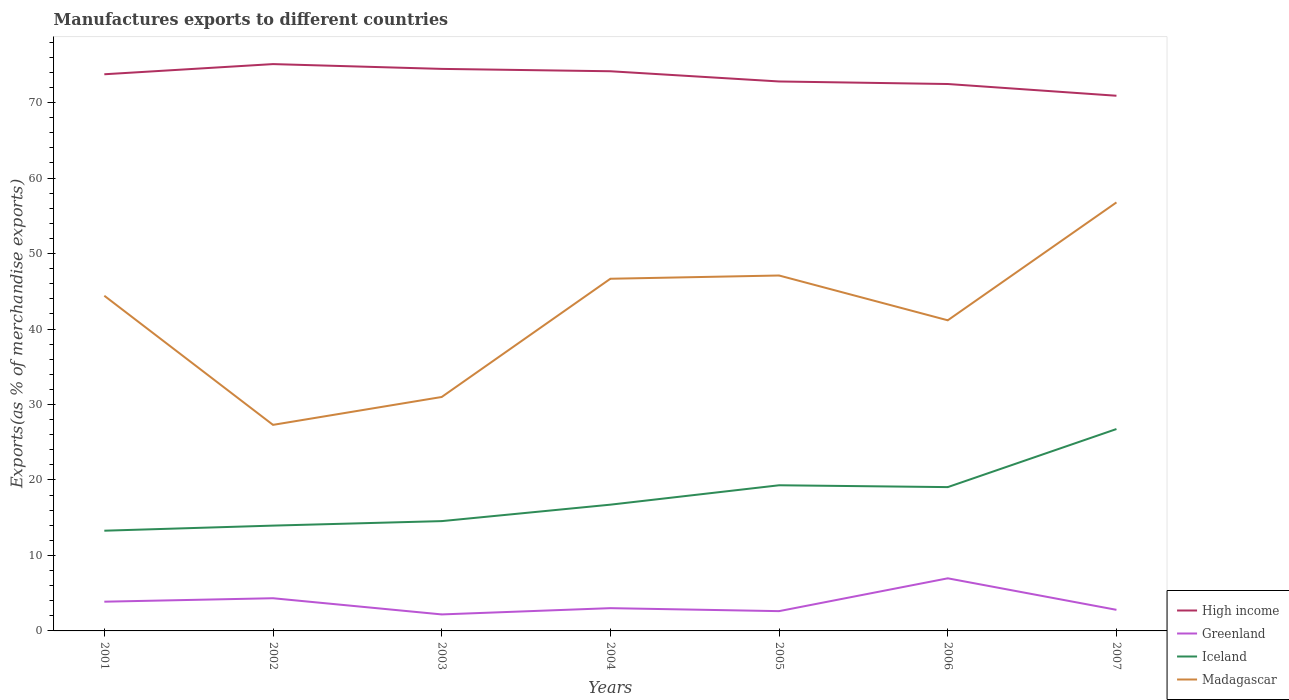Is the number of lines equal to the number of legend labels?
Your answer should be compact. Yes. Across all years, what is the maximum percentage of exports to different countries in Madagascar?
Make the answer very short. 27.3. What is the total percentage of exports to different countries in Iceland in the graph?
Offer a terse response. -3.45. What is the difference between the highest and the second highest percentage of exports to different countries in Greenland?
Offer a very short reply. 4.78. How many years are there in the graph?
Give a very brief answer. 7. Does the graph contain grids?
Give a very brief answer. No. What is the title of the graph?
Offer a very short reply. Manufactures exports to different countries. Does "Canada" appear as one of the legend labels in the graph?
Keep it short and to the point. No. What is the label or title of the Y-axis?
Make the answer very short. Exports(as % of merchandise exports). What is the Exports(as % of merchandise exports) of High income in 2001?
Ensure brevity in your answer.  73.76. What is the Exports(as % of merchandise exports) in Greenland in 2001?
Your answer should be very brief. 3.87. What is the Exports(as % of merchandise exports) in Iceland in 2001?
Provide a short and direct response. 13.28. What is the Exports(as % of merchandise exports) of Madagascar in 2001?
Provide a short and direct response. 44.41. What is the Exports(as % of merchandise exports) in High income in 2002?
Ensure brevity in your answer.  75.1. What is the Exports(as % of merchandise exports) in Greenland in 2002?
Ensure brevity in your answer.  4.33. What is the Exports(as % of merchandise exports) of Iceland in 2002?
Offer a terse response. 13.95. What is the Exports(as % of merchandise exports) of Madagascar in 2002?
Keep it short and to the point. 27.3. What is the Exports(as % of merchandise exports) in High income in 2003?
Give a very brief answer. 74.47. What is the Exports(as % of merchandise exports) in Greenland in 2003?
Your answer should be compact. 2.19. What is the Exports(as % of merchandise exports) in Iceland in 2003?
Give a very brief answer. 14.55. What is the Exports(as % of merchandise exports) of Madagascar in 2003?
Offer a very short reply. 31. What is the Exports(as % of merchandise exports) in High income in 2004?
Offer a very short reply. 74.16. What is the Exports(as % of merchandise exports) in Greenland in 2004?
Provide a short and direct response. 3.02. What is the Exports(as % of merchandise exports) in Iceland in 2004?
Give a very brief answer. 16.73. What is the Exports(as % of merchandise exports) in Madagascar in 2004?
Your response must be concise. 46.66. What is the Exports(as % of merchandise exports) of High income in 2005?
Your response must be concise. 72.8. What is the Exports(as % of merchandise exports) in Greenland in 2005?
Ensure brevity in your answer.  2.62. What is the Exports(as % of merchandise exports) of Iceland in 2005?
Provide a succinct answer. 19.3. What is the Exports(as % of merchandise exports) of Madagascar in 2005?
Keep it short and to the point. 47.09. What is the Exports(as % of merchandise exports) in High income in 2006?
Make the answer very short. 72.47. What is the Exports(as % of merchandise exports) of Greenland in 2006?
Your answer should be compact. 6.97. What is the Exports(as % of merchandise exports) of Iceland in 2006?
Provide a succinct answer. 19.05. What is the Exports(as % of merchandise exports) in Madagascar in 2006?
Make the answer very short. 41.16. What is the Exports(as % of merchandise exports) of High income in 2007?
Offer a terse response. 70.91. What is the Exports(as % of merchandise exports) in Greenland in 2007?
Ensure brevity in your answer.  2.8. What is the Exports(as % of merchandise exports) of Iceland in 2007?
Your response must be concise. 26.75. What is the Exports(as % of merchandise exports) of Madagascar in 2007?
Provide a succinct answer. 56.78. Across all years, what is the maximum Exports(as % of merchandise exports) of High income?
Provide a short and direct response. 75.1. Across all years, what is the maximum Exports(as % of merchandise exports) of Greenland?
Make the answer very short. 6.97. Across all years, what is the maximum Exports(as % of merchandise exports) of Iceland?
Ensure brevity in your answer.  26.75. Across all years, what is the maximum Exports(as % of merchandise exports) in Madagascar?
Your response must be concise. 56.78. Across all years, what is the minimum Exports(as % of merchandise exports) in High income?
Make the answer very short. 70.91. Across all years, what is the minimum Exports(as % of merchandise exports) in Greenland?
Offer a very short reply. 2.19. Across all years, what is the minimum Exports(as % of merchandise exports) of Iceland?
Provide a succinct answer. 13.28. Across all years, what is the minimum Exports(as % of merchandise exports) of Madagascar?
Provide a short and direct response. 27.3. What is the total Exports(as % of merchandise exports) in High income in the graph?
Your answer should be compact. 513.66. What is the total Exports(as % of merchandise exports) of Greenland in the graph?
Your response must be concise. 25.8. What is the total Exports(as % of merchandise exports) of Iceland in the graph?
Make the answer very short. 123.61. What is the total Exports(as % of merchandise exports) of Madagascar in the graph?
Provide a succinct answer. 294.4. What is the difference between the Exports(as % of merchandise exports) in High income in 2001 and that in 2002?
Keep it short and to the point. -1.35. What is the difference between the Exports(as % of merchandise exports) in Greenland in 2001 and that in 2002?
Offer a terse response. -0.46. What is the difference between the Exports(as % of merchandise exports) of Iceland in 2001 and that in 2002?
Ensure brevity in your answer.  -0.68. What is the difference between the Exports(as % of merchandise exports) in Madagascar in 2001 and that in 2002?
Your answer should be very brief. 17.11. What is the difference between the Exports(as % of merchandise exports) of High income in 2001 and that in 2003?
Your answer should be compact. -0.71. What is the difference between the Exports(as % of merchandise exports) of Greenland in 2001 and that in 2003?
Make the answer very short. 1.69. What is the difference between the Exports(as % of merchandise exports) of Iceland in 2001 and that in 2003?
Offer a terse response. -1.27. What is the difference between the Exports(as % of merchandise exports) of Madagascar in 2001 and that in 2003?
Keep it short and to the point. 13.41. What is the difference between the Exports(as % of merchandise exports) of High income in 2001 and that in 2004?
Give a very brief answer. -0.4. What is the difference between the Exports(as % of merchandise exports) in Greenland in 2001 and that in 2004?
Provide a succinct answer. 0.86. What is the difference between the Exports(as % of merchandise exports) in Iceland in 2001 and that in 2004?
Ensure brevity in your answer.  -3.45. What is the difference between the Exports(as % of merchandise exports) in Madagascar in 2001 and that in 2004?
Keep it short and to the point. -2.25. What is the difference between the Exports(as % of merchandise exports) of High income in 2001 and that in 2005?
Your answer should be very brief. 0.95. What is the difference between the Exports(as % of merchandise exports) in Greenland in 2001 and that in 2005?
Your response must be concise. 1.25. What is the difference between the Exports(as % of merchandise exports) of Iceland in 2001 and that in 2005?
Keep it short and to the point. -6.02. What is the difference between the Exports(as % of merchandise exports) in Madagascar in 2001 and that in 2005?
Make the answer very short. -2.68. What is the difference between the Exports(as % of merchandise exports) of High income in 2001 and that in 2006?
Make the answer very short. 1.29. What is the difference between the Exports(as % of merchandise exports) of Greenland in 2001 and that in 2006?
Offer a terse response. -3.1. What is the difference between the Exports(as % of merchandise exports) of Iceland in 2001 and that in 2006?
Your answer should be very brief. -5.78. What is the difference between the Exports(as % of merchandise exports) of Madagascar in 2001 and that in 2006?
Give a very brief answer. 3.25. What is the difference between the Exports(as % of merchandise exports) of High income in 2001 and that in 2007?
Give a very brief answer. 2.85. What is the difference between the Exports(as % of merchandise exports) in Greenland in 2001 and that in 2007?
Offer a terse response. 1.08. What is the difference between the Exports(as % of merchandise exports) in Iceland in 2001 and that in 2007?
Keep it short and to the point. -13.47. What is the difference between the Exports(as % of merchandise exports) of Madagascar in 2001 and that in 2007?
Your answer should be very brief. -12.37. What is the difference between the Exports(as % of merchandise exports) in High income in 2002 and that in 2003?
Your answer should be compact. 0.64. What is the difference between the Exports(as % of merchandise exports) of Greenland in 2002 and that in 2003?
Ensure brevity in your answer.  2.14. What is the difference between the Exports(as % of merchandise exports) of Iceland in 2002 and that in 2003?
Make the answer very short. -0.59. What is the difference between the Exports(as % of merchandise exports) in Madagascar in 2002 and that in 2003?
Ensure brevity in your answer.  -3.69. What is the difference between the Exports(as % of merchandise exports) in High income in 2002 and that in 2004?
Offer a very short reply. 0.95. What is the difference between the Exports(as % of merchandise exports) in Greenland in 2002 and that in 2004?
Ensure brevity in your answer.  1.31. What is the difference between the Exports(as % of merchandise exports) in Iceland in 2002 and that in 2004?
Offer a terse response. -2.77. What is the difference between the Exports(as % of merchandise exports) of Madagascar in 2002 and that in 2004?
Your response must be concise. -19.36. What is the difference between the Exports(as % of merchandise exports) in High income in 2002 and that in 2005?
Keep it short and to the point. 2.3. What is the difference between the Exports(as % of merchandise exports) of Greenland in 2002 and that in 2005?
Provide a short and direct response. 1.71. What is the difference between the Exports(as % of merchandise exports) of Iceland in 2002 and that in 2005?
Your answer should be compact. -5.34. What is the difference between the Exports(as % of merchandise exports) of Madagascar in 2002 and that in 2005?
Your answer should be compact. -19.79. What is the difference between the Exports(as % of merchandise exports) in High income in 2002 and that in 2006?
Ensure brevity in your answer.  2.64. What is the difference between the Exports(as % of merchandise exports) in Greenland in 2002 and that in 2006?
Provide a succinct answer. -2.64. What is the difference between the Exports(as % of merchandise exports) in Iceland in 2002 and that in 2006?
Keep it short and to the point. -5.1. What is the difference between the Exports(as % of merchandise exports) in Madagascar in 2002 and that in 2006?
Provide a short and direct response. -13.86. What is the difference between the Exports(as % of merchandise exports) of High income in 2002 and that in 2007?
Provide a short and direct response. 4.2. What is the difference between the Exports(as % of merchandise exports) of Greenland in 2002 and that in 2007?
Give a very brief answer. 1.54. What is the difference between the Exports(as % of merchandise exports) of Iceland in 2002 and that in 2007?
Your answer should be compact. -12.79. What is the difference between the Exports(as % of merchandise exports) in Madagascar in 2002 and that in 2007?
Your answer should be compact. -29.48. What is the difference between the Exports(as % of merchandise exports) in High income in 2003 and that in 2004?
Your answer should be compact. 0.31. What is the difference between the Exports(as % of merchandise exports) in Greenland in 2003 and that in 2004?
Give a very brief answer. -0.83. What is the difference between the Exports(as % of merchandise exports) of Iceland in 2003 and that in 2004?
Offer a very short reply. -2.18. What is the difference between the Exports(as % of merchandise exports) in Madagascar in 2003 and that in 2004?
Offer a terse response. -15.67. What is the difference between the Exports(as % of merchandise exports) in High income in 2003 and that in 2005?
Offer a terse response. 1.67. What is the difference between the Exports(as % of merchandise exports) in Greenland in 2003 and that in 2005?
Your answer should be very brief. -0.44. What is the difference between the Exports(as % of merchandise exports) in Iceland in 2003 and that in 2005?
Offer a terse response. -4.75. What is the difference between the Exports(as % of merchandise exports) of Madagascar in 2003 and that in 2005?
Your response must be concise. -16.1. What is the difference between the Exports(as % of merchandise exports) of High income in 2003 and that in 2006?
Your response must be concise. 2. What is the difference between the Exports(as % of merchandise exports) in Greenland in 2003 and that in 2006?
Give a very brief answer. -4.78. What is the difference between the Exports(as % of merchandise exports) in Iceland in 2003 and that in 2006?
Provide a succinct answer. -4.51. What is the difference between the Exports(as % of merchandise exports) of Madagascar in 2003 and that in 2006?
Provide a succinct answer. -10.16. What is the difference between the Exports(as % of merchandise exports) in High income in 2003 and that in 2007?
Your answer should be very brief. 3.56. What is the difference between the Exports(as % of merchandise exports) of Greenland in 2003 and that in 2007?
Keep it short and to the point. -0.61. What is the difference between the Exports(as % of merchandise exports) in Iceland in 2003 and that in 2007?
Ensure brevity in your answer.  -12.2. What is the difference between the Exports(as % of merchandise exports) of Madagascar in 2003 and that in 2007?
Provide a short and direct response. -25.78. What is the difference between the Exports(as % of merchandise exports) in High income in 2004 and that in 2005?
Offer a terse response. 1.35. What is the difference between the Exports(as % of merchandise exports) of Greenland in 2004 and that in 2005?
Offer a terse response. 0.4. What is the difference between the Exports(as % of merchandise exports) of Iceland in 2004 and that in 2005?
Ensure brevity in your answer.  -2.57. What is the difference between the Exports(as % of merchandise exports) in Madagascar in 2004 and that in 2005?
Keep it short and to the point. -0.43. What is the difference between the Exports(as % of merchandise exports) of High income in 2004 and that in 2006?
Your answer should be compact. 1.69. What is the difference between the Exports(as % of merchandise exports) of Greenland in 2004 and that in 2006?
Provide a short and direct response. -3.95. What is the difference between the Exports(as % of merchandise exports) in Iceland in 2004 and that in 2006?
Offer a very short reply. -2.33. What is the difference between the Exports(as % of merchandise exports) of Madagascar in 2004 and that in 2006?
Provide a succinct answer. 5.51. What is the difference between the Exports(as % of merchandise exports) in High income in 2004 and that in 2007?
Keep it short and to the point. 3.25. What is the difference between the Exports(as % of merchandise exports) of Greenland in 2004 and that in 2007?
Provide a succinct answer. 0.22. What is the difference between the Exports(as % of merchandise exports) in Iceland in 2004 and that in 2007?
Your response must be concise. -10.02. What is the difference between the Exports(as % of merchandise exports) of Madagascar in 2004 and that in 2007?
Ensure brevity in your answer.  -10.12. What is the difference between the Exports(as % of merchandise exports) in High income in 2005 and that in 2006?
Make the answer very short. 0.34. What is the difference between the Exports(as % of merchandise exports) of Greenland in 2005 and that in 2006?
Provide a short and direct response. -4.35. What is the difference between the Exports(as % of merchandise exports) in Iceland in 2005 and that in 2006?
Keep it short and to the point. 0.24. What is the difference between the Exports(as % of merchandise exports) in Madagascar in 2005 and that in 2006?
Your answer should be very brief. 5.94. What is the difference between the Exports(as % of merchandise exports) of High income in 2005 and that in 2007?
Offer a very short reply. 1.89. What is the difference between the Exports(as % of merchandise exports) of Greenland in 2005 and that in 2007?
Your answer should be compact. -0.17. What is the difference between the Exports(as % of merchandise exports) of Iceland in 2005 and that in 2007?
Give a very brief answer. -7.45. What is the difference between the Exports(as % of merchandise exports) of Madagascar in 2005 and that in 2007?
Offer a very short reply. -9.69. What is the difference between the Exports(as % of merchandise exports) in High income in 2006 and that in 2007?
Your answer should be very brief. 1.56. What is the difference between the Exports(as % of merchandise exports) in Greenland in 2006 and that in 2007?
Make the answer very short. 4.17. What is the difference between the Exports(as % of merchandise exports) of Iceland in 2006 and that in 2007?
Provide a succinct answer. -7.69. What is the difference between the Exports(as % of merchandise exports) of Madagascar in 2006 and that in 2007?
Keep it short and to the point. -15.62. What is the difference between the Exports(as % of merchandise exports) of High income in 2001 and the Exports(as % of merchandise exports) of Greenland in 2002?
Give a very brief answer. 69.43. What is the difference between the Exports(as % of merchandise exports) of High income in 2001 and the Exports(as % of merchandise exports) of Iceland in 2002?
Offer a very short reply. 59.8. What is the difference between the Exports(as % of merchandise exports) in High income in 2001 and the Exports(as % of merchandise exports) in Madagascar in 2002?
Provide a short and direct response. 46.46. What is the difference between the Exports(as % of merchandise exports) of Greenland in 2001 and the Exports(as % of merchandise exports) of Iceland in 2002?
Provide a short and direct response. -10.08. What is the difference between the Exports(as % of merchandise exports) in Greenland in 2001 and the Exports(as % of merchandise exports) in Madagascar in 2002?
Offer a terse response. -23.43. What is the difference between the Exports(as % of merchandise exports) of Iceland in 2001 and the Exports(as % of merchandise exports) of Madagascar in 2002?
Offer a very short reply. -14.02. What is the difference between the Exports(as % of merchandise exports) in High income in 2001 and the Exports(as % of merchandise exports) in Greenland in 2003?
Give a very brief answer. 71.57. What is the difference between the Exports(as % of merchandise exports) in High income in 2001 and the Exports(as % of merchandise exports) in Iceland in 2003?
Ensure brevity in your answer.  59.21. What is the difference between the Exports(as % of merchandise exports) of High income in 2001 and the Exports(as % of merchandise exports) of Madagascar in 2003?
Your answer should be compact. 42.76. What is the difference between the Exports(as % of merchandise exports) in Greenland in 2001 and the Exports(as % of merchandise exports) in Iceland in 2003?
Offer a very short reply. -10.67. What is the difference between the Exports(as % of merchandise exports) of Greenland in 2001 and the Exports(as % of merchandise exports) of Madagascar in 2003?
Your answer should be compact. -27.12. What is the difference between the Exports(as % of merchandise exports) in Iceland in 2001 and the Exports(as % of merchandise exports) in Madagascar in 2003?
Offer a terse response. -17.72. What is the difference between the Exports(as % of merchandise exports) in High income in 2001 and the Exports(as % of merchandise exports) in Greenland in 2004?
Your answer should be very brief. 70.74. What is the difference between the Exports(as % of merchandise exports) of High income in 2001 and the Exports(as % of merchandise exports) of Iceland in 2004?
Provide a short and direct response. 57.03. What is the difference between the Exports(as % of merchandise exports) of High income in 2001 and the Exports(as % of merchandise exports) of Madagascar in 2004?
Ensure brevity in your answer.  27.09. What is the difference between the Exports(as % of merchandise exports) in Greenland in 2001 and the Exports(as % of merchandise exports) in Iceland in 2004?
Your response must be concise. -12.85. What is the difference between the Exports(as % of merchandise exports) of Greenland in 2001 and the Exports(as % of merchandise exports) of Madagascar in 2004?
Offer a terse response. -42.79. What is the difference between the Exports(as % of merchandise exports) of Iceland in 2001 and the Exports(as % of merchandise exports) of Madagascar in 2004?
Provide a succinct answer. -33.39. What is the difference between the Exports(as % of merchandise exports) of High income in 2001 and the Exports(as % of merchandise exports) of Greenland in 2005?
Offer a very short reply. 71.14. What is the difference between the Exports(as % of merchandise exports) in High income in 2001 and the Exports(as % of merchandise exports) in Iceland in 2005?
Ensure brevity in your answer.  54.46. What is the difference between the Exports(as % of merchandise exports) of High income in 2001 and the Exports(as % of merchandise exports) of Madagascar in 2005?
Offer a very short reply. 26.66. What is the difference between the Exports(as % of merchandise exports) of Greenland in 2001 and the Exports(as % of merchandise exports) of Iceland in 2005?
Keep it short and to the point. -15.42. What is the difference between the Exports(as % of merchandise exports) of Greenland in 2001 and the Exports(as % of merchandise exports) of Madagascar in 2005?
Your response must be concise. -43.22. What is the difference between the Exports(as % of merchandise exports) of Iceland in 2001 and the Exports(as % of merchandise exports) of Madagascar in 2005?
Give a very brief answer. -33.81. What is the difference between the Exports(as % of merchandise exports) of High income in 2001 and the Exports(as % of merchandise exports) of Greenland in 2006?
Your answer should be compact. 66.79. What is the difference between the Exports(as % of merchandise exports) of High income in 2001 and the Exports(as % of merchandise exports) of Iceland in 2006?
Provide a short and direct response. 54.7. What is the difference between the Exports(as % of merchandise exports) in High income in 2001 and the Exports(as % of merchandise exports) in Madagascar in 2006?
Ensure brevity in your answer.  32.6. What is the difference between the Exports(as % of merchandise exports) in Greenland in 2001 and the Exports(as % of merchandise exports) in Iceland in 2006?
Keep it short and to the point. -15.18. What is the difference between the Exports(as % of merchandise exports) in Greenland in 2001 and the Exports(as % of merchandise exports) in Madagascar in 2006?
Your answer should be compact. -37.28. What is the difference between the Exports(as % of merchandise exports) of Iceland in 2001 and the Exports(as % of merchandise exports) of Madagascar in 2006?
Give a very brief answer. -27.88. What is the difference between the Exports(as % of merchandise exports) in High income in 2001 and the Exports(as % of merchandise exports) in Greenland in 2007?
Give a very brief answer. 70.96. What is the difference between the Exports(as % of merchandise exports) in High income in 2001 and the Exports(as % of merchandise exports) in Iceland in 2007?
Provide a succinct answer. 47.01. What is the difference between the Exports(as % of merchandise exports) of High income in 2001 and the Exports(as % of merchandise exports) of Madagascar in 2007?
Your response must be concise. 16.98. What is the difference between the Exports(as % of merchandise exports) of Greenland in 2001 and the Exports(as % of merchandise exports) of Iceland in 2007?
Ensure brevity in your answer.  -22.88. What is the difference between the Exports(as % of merchandise exports) in Greenland in 2001 and the Exports(as % of merchandise exports) in Madagascar in 2007?
Provide a short and direct response. -52.9. What is the difference between the Exports(as % of merchandise exports) of Iceland in 2001 and the Exports(as % of merchandise exports) of Madagascar in 2007?
Give a very brief answer. -43.5. What is the difference between the Exports(as % of merchandise exports) in High income in 2002 and the Exports(as % of merchandise exports) in Greenland in 2003?
Keep it short and to the point. 72.92. What is the difference between the Exports(as % of merchandise exports) in High income in 2002 and the Exports(as % of merchandise exports) in Iceland in 2003?
Provide a short and direct response. 60.56. What is the difference between the Exports(as % of merchandise exports) in High income in 2002 and the Exports(as % of merchandise exports) in Madagascar in 2003?
Provide a short and direct response. 44.11. What is the difference between the Exports(as % of merchandise exports) in Greenland in 2002 and the Exports(as % of merchandise exports) in Iceland in 2003?
Your answer should be very brief. -10.22. What is the difference between the Exports(as % of merchandise exports) of Greenland in 2002 and the Exports(as % of merchandise exports) of Madagascar in 2003?
Provide a short and direct response. -26.66. What is the difference between the Exports(as % of merchandise exports) in Iceland in 2002 and the Exports(as % of merchandise exports) in Madagascar in 2003?
Give a very brief answer. -17.04. What is the difference between the Exports(as % of merchandise exports) in High income in 2002 and the Exports(as % of merchandise exports) in Greenland in 2004?
Your answer should be very brief. 72.09. What is the difference between the Exports(as % of merchandise exports) of High income in 2002 and the Exports(as % of merchandise exports) of Iceland in 2004?
Offer a terse response. 58.38. What is the difference between the Exports(as % of merchandise exports) in High income in 2002 and the Exports(as % of merchandise exports) in Madagascar in 2004?
Offer a terse response. 28.44. What is the difference between the Exports(as % of merchandise exports) in Greenland in 2002 and the Exports(as % of merchandise exports) in Iceland in 2004?
Provide a succinct answer. -12.4. What is the difference between the Exports(as % of merchandise exports) in Greenland in 2002 and the Exports(as % of merchandise exports) in Madagascar in 2004?
Your answer should be compact. -42.33. What is the difference between the Exports(as % of merchandise exports) in Iceland in 2002 and the Exports(as % of merchandise exports) in Madagascar in 2004?
Provide a succinct answer. -32.71. What is the difference between the Exports(as % of merchandise exports) in High income in 2002 and the Exports(as % of merchandise exports) in Greenland in 2005?
Offer a very short reply. 72.48. What is the difference between the Exports(as % of merchandise exports) in High income in 2002 and the Exports(as % of merchandise exports) in Iceland in 2005?
Give a very brief answer. 55.81. What is the difference between the Exports(as % of merchandise exports) in High income in 2002 and the Exports(as % of merchandise exports) in Madagascar in 2005?
Ensure brevity in your answer.  28.01. What is the difference between the Exports(as % of merchandise exports) of Greenland in 2002 and the Exports(as % of merchandise exports) of Iceland in 2005?
Provide a succinct answer. -14.97. What is the difference between the Exports(as % of merchandise exports) in Greenland in 2002 and the Exports(as % of merchandise exports) in Madagascar in 2005?
Your response must be concise. -42.76. What is the difference between the Exports(as % of merchandise exports) of Iceland in 2002 and the Exports(as % of merchandise exports) of Madagascar in 2005?
Your answer should be very brief. -33.14. What is the difference between the Exports(as % of merchandise exports) of High income in 2002 and the Exports(as % of merchandise exports) of Greenland in 2006?
Ensure brevity in your answer.  68.13. What is the difference between the Exports(as % of merchandise exports) in High income in 2002 and the Exports(as % of merchandise exports) in Iceland in 2006?
Your response must be concise. 56.05. What is the difference between the Exports(as % of merchandise exports) of High income in 2002 and the Exports(as % of merchandise exports) of Madagascar in 2006?
Ensure brevity in your answer.  33.95. What is the difference between the Exports(as % of merchandise exports) in Greenland in 2002 and the Exports(as % of merchandise exports) in Iceland in 2006?
Offer a very short reply. -14.72. What is the difference between the Exports(as % of merchandise exports) in Greenland in 2002 and the Exports(as % of merchandise exports) in Madagascar in 2006?
Your answer should be compact. -36.83. What is the difference between the Exports(as % of merchandise exports) of Iceland in 2002 and the Exports(as % of merchandise exports) of Madagascar in 2006?
Give a very brief answer. -27.2. What is the difference between the Exports(as % of merchandise exports) of High income in 2002 and the Exports(as % of merchandise exports) of Greenland in 2007?
Your answer should be very brief. 72.31. What is the difference between the Exports(as % of merchandise exports) in High income in 2002 and the Exports(as % of merchandise exports) in Iceland in 2007?
Ensure brevity in your answer.  48.36. What is the difference between the Exports(as % of merchandise exports) of High income in 2002 and the Exports(as % of merchandise exports) of Madagascar in 2007?
Ensure brevity in your answer.  18.33. What is the difference between the Exports(as % of merchandise exports) in Greenland in 2002 and the Exports(as % of merchandise exports) in Iceland in 2007?
Provide a short and direct response. -22.42. What is the difference between the Exports(as % of merchandise exports) in Greenland in 2002 and the Exports(as % of merchandise exports) in Madagascar in 2007?
Give a very brief answer. -52.45. What is the difference between the Exports(as % of merchandise exports) of Iceland in 2002 and the Exports(as % of merchandise exports) of Madagascar in 2007?
Offer a terse response. -42.82. What is the difference between the Exports(as % of merchandise exports) of High income in 2003 and the Exports(as % of merchandise exports) of Greenland in 2004?
Offer a terse response. 71.45. What is the difference between the Exports(as % of merchandise exports) of High income in 2003 and the Exports(as % of merchandise exports) of Iceland in 2004?
Make the answer very short. 57.74. What is the difference between the Exports(as % of merchandise exports) in High income in 2003 and the Exports(as % of merchandise exports) in Madagascar in 2004?
Give a very brief answer. 27.8. What is the difference between the Exports(as % of merchandise exports) of Greenland in 2003 and the Exports(as % of merchandise exports) of Iceland in 2004?
Provide a succinct answer. -14.54. What is the difference between the Exports(as % of merchandise exports) in Greenland in 2003 and the Exports(as % of merchandise exports) in Madagascar in 2004?
Provide a succinct answer. -44.48. What is the difference between the Exports(as % of merchandise exports) of Iceland in 2003 and the Exports(as % of merchandise exports) of Madagascar in 2004?
Offer a terse response. -32.11. What is the difference between the Exports(as % of merchandise exports) of High income in 2003 and the Exports(as % of merchandise exports) of Greenland in 2005?
Offer a very short reply. 71.85. What is the difference between the Exports(as % of merchandise exports) in High income in 2003 and the Exports(as % of merchandise exports) in Iceland in 2005?
Your response must be concise. 55.17. What is the difference between the Exports(as % of merchandise exports) in High income in 2003 and the Exports(as % of merchandise exports) in Madagascar in 2005?
Your response must be concise. 27.38. What is the difference between the Exports(as % of merchandise exports) of Greenland in 2003 and the Exports(as % of merchandise exports) of Iceland in 2005?
Your answer should be very brief. -17.11. What is the difference between the Exports(as % of merchandise exports) in Greenland in 2003 and the Exports(as % of merchandise exports) in Madagascar in 2005?
Ensure brevity in your answer.  -44.91. What is the difference between the Exports(as % of merchandise exports) in Iceland in 2003 and the Exports(as % of merchandise exports) in Madagascar in 2005?
Provide a short and direct response. -32.54. What is the difference between the Exports(as % of merchandise exports) in High income in 2003 and the Exports(as % of merchandise exports) in Greenland in 2006?
Ensure brevity in your answer.  67.5. What is the difference between the Exports(as % of merchandise exports) in High income in 2003 and the Exports(as % of merchandise exports) in Iceland in 2006?
Your response must be concise. 55.41. What is the difference between the Exports(as % of merchandise exports) in High income in 2003 and the Exports(as % of merchandise exports) in Madagascar in 2006?
Provide a succinct answer. 33.31. What is the difference between the Exports(as % of merchandise exports) of Greenland in 2003 and the Exports(as % of merchandise exports) of Iceland in 2006?
Your answer should be compact. -16.87. What is the difference between the Exports(as % of merchandise exports) in Greenland in 2003 and the Exports(as % of merchandise exports) in Madagascar in 2006?
Offer a very short reply. -38.97. What is the difference between the Exports(as % of merchandise exports) of Iceland in 2003 and the Exports(as % of merchandise exports) of Madagascar in 2006?
Ensure brevity in your answer.  -26.61. What is the difference between the Exports(as % of merchandise exports) in High income in 2003 and the Exports(as % of merchandise exports) in Greenland in 2007?
Provide a short and direct response. 71.67. What is the difference between the Exports(as % of merchandise exports) in High income in 2003 and the Exports(as % of merchandise exports) in Iceland in 2007?
Make the answer very short. 47.72. What is the difference between the Exports(as % of merchandise exports) in High income in 2003 and the Exports(as % of merchandise exports) in Madagascar in 2007?
Give a very brief answer. 17.69. What is the difference between the Exports(as % of merchandise exports) of Greenland in 2003 and the Exports(as % of merchandise exports) of Iceland in 2007?
Your response must be concise. -24.56. What is the difference between the Exports(as % of merchandise exports) of Greenland in 2003 and the Exports(as % of merchandise exports) of Madagascar in 2007?
Give a very brief answer. -54.59. What is the difference between the Exports(as % of merchandise exports) in Iceland in 2003 and the Exports(as % of merchandise exports) in Madagascar in 2007?
Offer a very short reply. -42.23. What is the difference between the Exports(as % of merchandise exports) of High income in 2004 and the Exports(as % of merchandise exports) of Greenland in 2005?
Offer a very short reply. 71.54. What is the difference between the Exports(as % of merchandise exports) in High income in 2004 and the Exports(as % of merchandise exports) in Iceland in 2005?
Make the answer very short. 54.86. What is the difference between the Exports(as % of merchandise exports) of High income in 2004 and the Exports(as % of merchandise exports) of Madagascar in 2005?
Provide a succinct answer. 27.06. What is the difference between the Exports(as % of merchandise exports) of Greenland in 2004 and the Exports(as % of merchandise exports) of Iceland in 2005?
Your answer should be compact. -16.28. What is the difference between the Exports(as % of merchandise exports) in Greenland in 2004 and the Exports(as % of merchandise exports) in Madagascar in 2005?
Ensure brevity in your answer.  -44.08. What is the difference between the Exports(as % of merchandise exports) in Iceland in 2004 and the Exports(as % of merchandise exports) in Madagascar in 2005?
Your answer should be compact. -30.36. What is the difference between the Exports(as % of merchandise exports) of High income in 2004 and the Exports(as % of merchandise exports) of Greenland in 2006?
Your response must be concise. 67.19. What is the difference between the Exports(as % of merchandise exports) in High income in 2004 and the Exports(as % of merchandise exports) in Iceland in 2006?
Offer a very short reply. 55.1. What is the difference between the Exports(as % of merchandise exports) in High income in 2004 and the Exports(as % of merchandise exports) in Madagascar in 2006?
Provide a short and direct response. 33. What is the difference between the Exports(as % of merchandise exports) of Greenland in 2004 and the Exports(as % of merchandise exports) of Iceland in 2006?
Provide a succinct answer. -16.04. What is the difference between the Exports(as % of merchandise exports) of Greenland in 2004 and the Exports(as % of merchandise exports) of Madagascar in 2006?
Ensure brevity in your answer.  -38.14. What is the difference between the Exports(as % of merchandise exports) of Iceland in 2004 and the Exports(as % of merchandise exports) of Madagascar in 2006?
Your response must be concise. -24.43. What is the difference between the Exports(as % of merchandise exports) in High income in 2004 and the Exports(as % of merchandise exports) in Greenland in 2007?
Your answer should be very brief. 71.36. What is the difference between the Exports(as % of merchandise exports) of High income in 2004 and the Exports(as % of merchandise exports) of Iceland in 2007?
Make the answer very short. 47.41. What is the difference between the Exports(as % of merchandise exports) in High income in 2004 and the Exports(as % of merchandise exports) in Madagascar in 2007?
Your answer should be compact. 17.38. What is the difference between the Exports(as % of merchandise exports) in Greenland in 2004 and the Exports(as % of merchandise exports) in Iceland in 2007?
Provide a short and direct response. -23.73. What is the difference between the Exports(as % of merchandise exports) in Greenland in 2004 and the Exports(as % of merchandise exports) in Madagascar in 2007?
Your answer should be compact. -53.76. What is the difference between the Exports(as % of merchandise exports) in Iceland in 2004 and the Exports(as % of merchandise exports) in Madagascar in 2007?
Offer a very short reply. -40.05. What is the difference between the Exports(as % of merchandise exports) of High income in 2005 and the Exports(as % of merchandise exports) of Greenland in 2006?
Your answer should be compact. 65.83. What is the difference between the Exports(as % of merchandise exports) of High income in 2005 and the Exports(as % of merchandise exports) of Iceland in 2006?
Give a very brief answer. 53.75. What is the difference between the Exports(as % of merchandise exports) in High income in 2005 and the Exports(as % of merchandise exports) in Madagascar in 2006?
Provide a short and direct response. 31.64. What is the difference between the Exports(as % of merchandise exports) of Greenland in 2005 and the Exports(as % of merchandise exports) of Iceland in 2006?
Keep it short and to the point. -16.43. What is the difference between the Exports(as % of merchandise exports) in Greenland in 2005 and the Exports(as % of merchandise exports) in Madagascar in 2006?
Give a very brief answer. -38.54. What is the difference between the Exports(as % of merchandise exports) in Iceland in 2005 and the Exports(as % of merchandise exports) in Madagascar in 2006?
Your answer should be compact. -21.86. What is the difference between the Exports(as % of merchandise exports) in High income in 2005 and the Exports(as % of merchandise exports) in Greenland in 2007?
Your answer should be very brief. 70.01. What is the difference between the Exports(as % of merchandise exports) in High income in 2005 and the Exports(as % of merchandise exports) in Iceland in 2007?
Give a very brief answer. 46.05. What is the difference between the Exports(as % of merchandise exports) of High income in 2005 and the Exports(as % of merchandise exports) of Madagascar in 2007?
Keep it short and to the point. 16.02. What is the difference between the Exports(as % of merchandise exports) in Greenland in 2005 and the Exports(as % of merchandise exports) in Iceland in 2007?
Provide a succinct answer. -24.13. What is the difference between the Exports(as % of merchandise exports) in Greenland in 2005 and the Exports(as % of merchandise exports) in Madagascar in 2007?
Make the answer very short. -54.16. What is the difference between the Exports(as % of merchandise exports) in Iceland in 2005 and the Exports(as % of merchandise exports) in Madagascar in 2007?
Offer a terse response. -37.48. What is the difference between the Exports(as % of merchandise exports) in High income in 2006 and the Exports(as % of merchandise exports) in Greenland in 2007?
Keep it short and to the point. 69.67. What is the difference between the Exports(as % of merchandise exports) in High income in 2006 and the Exports(as % of merchandise exports) in Iceland in 2007?
Offer a very short reply. 45.72. What is the difference between the Exports(as % of merchandise exports) of High income in 2006 and the Exports(as % of merchandise exports) of Madagascar in 2007?
Your answer should be compact. 15.69. What is the difference between the Exports(as % of merchandise exports) of Greenland in 2006 and the Exports(as % of merchandise exports) of Iceland in 2007?
Offer a very short reply. -19.78. What is the difference between the Exports(as % of merchandise exports) in Greenland in 2006 and the Exports(as % of merchandise exports) in Madagascar in 2007?
Your answer should be very brief. -49.81. What is the difference between the Exports(as % of merchandise exports) in Iceland in 2006 and the Exports(as % of merchandise exports) in Madagascar in 2007?
Make the answer very short. -37.72. What is the average Exports(as % of merchandise exports) in High income per year?
Give a very brief answer. 73.38. What is the average Exports(as % of merchandise exports) of Greenland per year?
Keep it short and to the point. 3.69. What is the average Exports(as % of merchandise exports) of Iceland per year?
Give a very brief answer. 17.66. What is the average Exports(as % of merchandise exports) in Madagascar per year?
Offer a very short reply. 42.06. In the year 2001, what is the difference between the Exports(as % of merchandise exports) in High income and Exports(as % of merchandise exports) in Greenland?
Offer a terse response. 69.88. In the year 2001, what is the difference between the Exports(as % of merchandise exports) in High income and Exports(as % of merchandise exports) in Iceland?
Your answer should be compact. 60.48. In the year 2001, what is the difference between the Exports(as % of merchandise exports) in High income and Exports(as % of merchandise exports) in Madagascar?
Offer a terse response. 29.35. In the year 2001, what is the difference between the Exports(as % of merchandise exports) in Greenland and Exports(as % of merchandise exports) in Iceland?
Give a very brief answer. -9.4. In the year 2001, what is the difference between the Exports(as % of merchandise exports) in Greenland and Exports(as % of merchandise exports) in Madagascar?
Provide a succinct answer. -40.54. In the year 2001, what is the difference between the Exports(as % of merchandise exports) of Iceland and Exports(as % of merchandise exports) of Madagascar?
Offer a terse response. -31.13. In the year 2002, what is the difference between the Exports(as % of merchandise exports) of High income and Exports(as % of merchandise exports) of Greenland?
Your answer should be very brief. 70.77. In the year 2002, what is the difference between the Exports(as % of merchandise exports) of High income and Exports(as % of merchandise exports) of Iceland?
Provide a short and direct response. 61.15. In the year 2002, what is the difference between the Exports(as % of merchandise exports) in High income and Exports(as % of merchandise exports) in Madagascar?
Give a very brief answer. 47.8. In the year 2002, what is the difference between the Exports(as % of merchandise exports) of Greenland and Exports(as % of merchandise exports) of Iceland?
Give a very brief answer. -9.62. In the year 2002, what is the difference between the Exports(as % of merchandise exports) of Greenland and Exports(as % of merchandise exports) of Madagascar?
Make the answer very short. -22.97. In the year 2002, what is the difference between the Exports(as % of merchandise exports) of Iceland and Exports(as % of merchandise exports) of Madagascar?
Your answer should be compact. -13.35. In the year 2003, what is the difference between the Exports(as % of merchandise exports) of High income and Exports(as % of merchandise exports) of Greenland?
Keep it short and to the point. 72.28. In the year 2003, what is the difference between the Exports(as % of merchandise exports) in High income and Exports(as % of merchandise exports) in Iceland?
Give a very brief answer. 59.92. In the year 2003, what is the difference between the Exports(as % of merchandise exports) of High income and Exports(as % of merchandise exports) of Madagascar?
Your answer should be compact. 43.47. In the year 2003, what is the difference between the Exports(as % of merchandise exports) in Greenland and Exports(as % of merchandise exports) in Iceland?
Offer a terse response. -12.36. In the year 2003, what is the difference between the Exports(as % of merchandise exports) in Greenland and Exports(as % of merchandise exports) in Madagascar?
Ensure brevity in your answer.  -28.81. In the year 2003, what is the difference between the Exports(as % of merchandise exports) in Iceland and Exports(as % of merchandise exports) in Madagascar?
Ensure brevity in your answer.  -16.45. In the year 2004, what is the difference between the Exports(as % of merchandise exports) of High income and Exports(as % of merchandise exports) of Greenland?
Offer a very short reply. 71.14. In the year 2004, what is the difference between the Exports(as % of merchandise exports) in High income and Exports(as % of merchandise exports) in Iceland?
Your answer should be compact. 57.43. In the year 2004, what is the difference between the Exports(as % of merchandise exports) of High income and Exports(as % of merchandise exports) of Madagascar?
Offer a terse response. 27.49. In the year 2004, what is the difference between the Exports(as % of merchandise exports) of Greenland and Exports(as % of merchandise exports) of Iceland?
Your response must be concise. -13.71. In the year 2004, what is the difference between the Exports(as % of merchandise exports) in Greenland and Exports(as % of merchandise exports) in Madagascar?
Ensure brevity in your answer.  -43.65. In the year 2004, what is the difference between the Exports(as % of merchandise exports) in Iceland and Exports(as % of merchandise exports) in Madagascar?
Give a very brief answer. -29.93. In the year 2005, what is the difference between the Exports(as % of merchandise exports) of High income and Exports(as % of merchandise exports) of Greenland?
Your response must be concise. 70.18. In the year 2005, what is the difference between the Exports(as % of merchandise exports) in High income and Exports(as % of merchandise exports) in Iceland?
Provide a succinct answer. 53.5. In the year 2005, what is the difference between the Exports(as % of merchandise exports) in High income and Exports(as % of merchandise exports) in Madagascar?
Offer a terse response. 25.71. In the year 2005, what is the difference between the Exports(as % of merchandise exports) of Greenland and Exports(as % of merchandise exports) of Iceland?
Your answer should be compact. -16.68. In the year 2005, what is the difference between the Exports(as % of merchandise exports) of Greenland and Exports(as % of merchandise exports) of Madagascar?
Your answer should be compact. -44.47. In the year 2005, what is the difference between the Exports(as % of merchandise exports) in Iceland and Exports(as % of merchandise exports) in Madagascar?
Your response must be concise. -27.79. In the year 2006, what is the difference between the Exports(as % of merchandise exports) in High income and Exports(as % of merchandise exports) in Greenland?
Keep it short and to the point. 65.5. In the year 2006, what is the difference between the Exports(as % of merchandise exports) in High income and Exports(as % of merchandise exports) in Iceland?
Ensure brevity in your answer.  53.41. In the year 2006, what is the difference between the Exports(as % of merchandise exports) in High income and Exports(as % of merchandise exports) in Madagascar?
Give a very brief answer. 31.31. In the year 2006, what is the difference between the Exports(as % of merchandise exports) in Greenland and Exports(as % of merchandise exports) in Iceland?
Provide a succinct answer. -12.08. In the year 2006, what is the difference between the Exports(as % of merchandise exports) of Greenland and Exports(as % of merchandise exports) of Madagascar?
Make the answer very short. -34.19. In the year 2006, what is the difference between the Exports(as % of merchandise exports) of Iceland and Exports(as % of merchandise exports) of Madagascar?
Offer a very short reply. -22.1. In the year 2007, what is the difference between the Exports(as % of merchandise exports) of High income and Exports(as % of merchandise exports) of Greenland?
Your answer should be compact. 68.11. In the year 2007, what is the difference between the Exports(as % of merchandise exports) of High income and Exports(as % of merchandise exports) of Iceland?
Give a very brief answer. 44.16. In the year 2007, what is the difference between the Exports(as % of merchandise exports) in High income and Exports(as % of merchandise exports) in Madagascar?
Keep it short and to the point. 14.13. In the year 2007, what is the difference between the Exports(as % of merchandise exports) of Greenland and Exports(as % of merchandise exports) of Iceland?
Provide a short and direct response. -23.95. In the year 2007, what is the difference between the Exports(as % of merchandise exports) in Greenland and Exports(as % of merchandise exports) in Madagascar?
Your answer should be compact. -53.98. In the year 2007, what is the difference between the Exports(as % of merchandise exports) of Iceland and Exports(as % of merchandise exports) of Madagascar?
Give a very brief answer. -30.03. What is the ratio of the Exports(as % of merchandise exports) in High income in 2001 to that in 2002?
Offer a terse response. 0.98. What is the ratio of the Exports(as % of merchandise exports) of Greenland in 2001 to that in 2002?
Offer a terse response. 0.89. What is the ratio of the Exports(as % of merchandise exports) of Iceland in 2001 to that in 2002?
Give a very brief answer. 0.95. What is the ratio of the Exports(as % of merchandise exports) in Madagascar in 2001 to that in 2002?
Offer a terse response. 1.63. What is the ratio of the Exports(as % of merchandise exports) of High income in 2001 to that in 2003?
Ensure brevity in your answer.  0.99. What is the ratio of the Exports(as % of merchandise exports) in Greenland in 2001 to that in 2003?
Make the answer very short. 1.77. What is the ratio of the Exports(as % of merchandise exports) of Iceland in 2001 to that in 2003?
Provide a short and direct response. 0.91. What is the ratio of the Exports(as % of merchandise exports) in Madagascar in 2001 to that in 2003?
Offer a very short reply. 1.43. What is the ratio of the Exports(as % of merchandise exports) in Greenland in 2001 to that in 2004?
Ensure brevity in your answer.  1.28. What is the ratio of the Exports(as % of merchandise exports) of Iceland in 2001 to that in 2004?
Offer a terse response. 0.79. What is the ratio of the Exports(as % of merchandise exports) in Madagascar in 2001 to that in 2004?
Provide a short and direct response. 0.95. What is the ratio of the Exports(as % of merchandise exports) in High income in 2001 to that in 2005?
Provide a succinct answer. 1.01. What is the ratio of the Exports(as % of merchandise exports) in Greenland in 2001 to that in 2005?
Ensure brevity in your answer.  1.48. What is the ratio of the Exports(as % of merchandise exports) in Iceland in 2001 to that in 2005?
Your answer should be very brief. 0.69. What is the ratio of the Exports(as % of merchandise exports) of Madagascar in 2001 to that in 2005?
Your response must be concise. 0.94. What is the ratio of the Exports(as % of merchandise exports) in High income in 2001 to that in 2006?
Ensure brevity in your answer.  1.02. What is the ratio of the Exports(as % of merchandise exports) of Greenland in 2001 to that in 2006?
Offer a terse response. 0.56. What is the ratio of the Exports(as % of merchandise exports) of Iceland in 2001 to that in 2006?
Ensure brevity in your answer.  0.7. What is the ratio of the Exports(as % of merchandise exports) in Madagascar in 2001 to that in 2006?
Provide a short and direct response. 1.08. What is the ratio of the Exports(as % of merchandise exports) in High income in 2001 to that in 2007?
Provide a short and direct response. 1.04. What is the ratio of the Exports(as % of merchandise exports) in Greenland in 2001 to that in 2007?
Ensure brevity in your answer.  1.39. What is the ratio of the Exports(as % of merchandise exports) of Iceland in 2001 to that in 2007?
Give a very brief answer. 0.5. What is the ratio of the Exports(as % of merchandise exports) of Madagascar in 2001 to that in 2007?
Make the answer very short. 0.78. What is the ratio of the Exports(as % of merchandise exports) of High income in 2002 to that in 2003?
Your answer should be compact. 1.01. What is the ratio of the Exports(as % of merchandise exports) in Greenland in 2002 to that in 2003?
Make the answer very short. 1.98. What is the ratio of the Exports(as % of merchandise exports) of Iceland in 2002 to that in 2003?
Offer a very short reply. 0.96. What is the ratio of the Exports(as % of merchandise exports) of Madagascar in 2002 to that in 2003?
Make the answer very short. 0.88. What is the ratio of the Exports(as % of merchandise exports) of High income in 2002 to that in 2004?
Your answer should be compact. 1.01. What is the ratio of the Exports(as % of merchandise exports) in Greenland in 2002 to that in 2004?
Ensure brevity in your answer.  1.44. What is the ratio of the Exports(as % of merchandise exports) of Iceland in 2002 to that in 2004?
Keep it short and to the point. 0.83. What is the ratio of the Exports(as % of merchandise exports) of Madagascar in 2002 to that in 2004?
Your answer should be compact. 0.59. What is the ratio of the Exports(as % of merchandise exports) in High income in 2002 to that in 2005?
Keep it short and to the point. 1.03. What is the ratio of the Exports(as % of merchandise exports) in Greenland in 2002 to that in 2005?
Offer a terse response. 1.65. What is the ratio of the Exports(as % of merchandise exports) of Iceland in 2002 to that in 2005?
Offer a terse response. 0.72. What is the ratio of the Exports(as % of merchandise exports) in Madagascar in 2002 to that in 2005?
Provide a succinct answer. 0.58. What is the ratio of the Exports(as % of merchandise exports) in High income in 2002 to that in 2006?
Give a very brief answer. 1.04. What is the ratio of the Exports(as % of merchandise exports) in Greenland in 2002 to that in 2006?
Offer a terse response. 0.62. What is the ratio of the Exports(as % of merchandise exports) in Iceland in 2002 to that in 2006?
Give a very brief answer. 0.73. What is the ratio of the Exports(as % of merchandise exports) in Madagascar in 2002 to that in 2006?
Make the answer very short. 0.66. What is the ratio of the Exports(as % of merchandise exports) in High income in 2002 to that in 2007?
Your answer should be compact. 1.06. What is the ratio of the Exports(as % of merchandise exports) in Greenland in 2002 to that in 2007?
Offer a very short reply. 1.55. What is the ratio of the Exports(as % of merchandise exports) in Iceland in 2002 to that in 2007?
Give a very brief answer. 0.52. What is the ratio of the Exports(as % of merchandise exports) in Madagascar in 2002 to that in 2007?
Make the answer very short. 0.48. What is the ratio of the Exports(as % of merchandise exports) of High income in 2003 to that in 2004?
Your answer should be compact. 1. What is the ratio of the Exports(as % of merchandise exports) in Greenland in 2003 to that in 2004?
Make the answer very short. 0.72. What is the ratio of the Exports(as % of merchandise exports) in Iceland in 2003 to that in 2004?
Give a very brief answer. 0.87. What is the ratio of the Exports(as % of merchandise exports) of Madagascar in 2003 to that in 2004?
Keep it short and to the point. 0.66. What is the ratio of the Exports(as % of merchandise exports) in High income in 2003 to that in 2005?
Provide a short and direct response. 1.02. What is the ratio of the Exports(as % of merchandise exports) of Greenland in 2003 to that in 2005?
Make the answer very short. 0.83. What is the ratio of the Exports(as % of merchandise exports) of Iceland in 2003 to that in 2005?
Your response must be concise. 0.75. What is the ratio of the Exports(as % of merchandise exports) of Madagascar in 2003 to that in 2005?
Your response must be concise. 0.66. What is the ratio of the Exports(as % of merchandise exports) of High income in 2003 to that in 2006?
Make the answer very short. 1.03. What is the ratio of the Exports(as % of merchandise exports) of Greenland in 2003 to that in 2006?
Offer a terse response. 0.31. What is the ratio of the Exports(as % of merchandise exports) of Iceland in 2003 to that in 2006?
Offer a very short reply. 0.76. What is the ratio of the Exports(as % of merchandise exports) of Madagascar in 2003 to that in 2006?
Your answer should be very brief. 0.75. What is the ratio of the Exports(as % of merchandise exports) of High income in 2003 to that in 2007?
Provide a short and direct response. 1.05. What is the ratio of the Exports(as % of merchandise exports) of Greenland in 2003 to that in 2007?
Offer a very short reply. 0.78. What is the ratio of the Exports(as % of merchandise exports) in Iceland in 2003 to that in 2007?
Give a very brief answer. 0.54. What is the ratio of the Exports(as % of merchandise exports) in Madagascar in 2003 to that in 2007?
Provide a short and direct response. 0.55. What is the ratio of the Exports(as % of merchandise exports) in High income in 2004 to that in 2005?
Offer a terse response. 1.02. What is the ratio of the Exports(as % of merchandise exports) in Greenland in 2004 to that in 2005?
Give a very brief answer. 1.15. What is the ratio of the Exports(as % of merchandise exports) of Iceland in 2004 to that in 2005?
Provide a short and direct response. 0.87. What is the ratio of the Exports(as % of merchandise exports) in Madagascar in 2004 to that in 2005?
Your response must be concise. 0.99. What is the ratio of the Exports(as % of merchandise exports) in High income in 2004 to that in 2006?
Offer a terse response. 1.02. What is the ratio of the Exports(as % of merchandise exports) in Greenland in 2004 to that in 2006?
Provide a succinct answer. 0.43. What is the ratio of the Exports(as % of merchandise exports) of Iceland in 2004 to that in 2006?
Offer a very short reply. 0.88. What is the ratio of the Exports(as % of merchandise exports) of Madagascar in 2004 to that in 2006?
Ensure brevity in your answer.  1.13. What is the ratio of the Exports(as % of merchandise exports) of High income in 2004 to that in 2007?
Ensure brevity in your answer.  1.05. What is the ratio of the Exports(as % of merchandise exports) of Greenland in 2004 to that in 2007?
Offer a terse response. 1.08. What is the ratio of the Exports(as % of merchandise exports) in Iceland in 2004 to that in 2007?
Offer a terse response. 0.63. What is the ratio of the Exports(as % of merchandise exports) in Madagascar in 2004 to that in 2007?
Your answer should be very brief. 0.82. What is the ratio of the Exports(as % of merchandise exports) of High income in 2005 to that in 2006?
Keep it short and to the point. 1. What is the ratio of the Exports(as % of merchandise exports) of Greenland in 2005 to that in 2006?
Offer a terse response. 0.38. What is the ratio of the Exports(as % of merchandise exports) of Iceland in 2005 to that in 2006?
Give a very brief answer. 1.01. What is the ratio of the Exports(as % of merchandise exports) in Madagascar in 2005 to that in 2006?
Provide a succinct answer. 1.14. What is the ratio of the Exports(as % of merchandise exports) of High income in 2005 to that in 2007?
Provide a short and direct response. 1.03. What is the ratio of the Exports(as % of merchandise exports) of Greenland in 2005 to that in 2007?
Your answer should be very brief. 0.94. What is the ratio of the Exports(as % of merchandise exports) in Iceland in 2005 to that in 2007?
Your answer should be very brief. 0.72. What is the ratio of the Exports(as % of merchandise exports) in Madagascar in 2005 to that in 2007?
Keep it short and to the point. 0.83. What is the ratio of the Exports(as % of merchandise exports) in High income in 2006 to that in 2007?
Provide a short and direct response. 1.02. What is the ratio of the Exports(as % of merchandise exports) in Greenland in 2006 to that in 2007?
Offer a terse response. 2.49. What is the ratio of the Exports(as % of merchandise exports) in Iceland in 2006 to that in 2007?
Your answer should be compact. 0.71. What is the ratio of the Exports(as % of merchandise exports) of Madagascar in 2006 to that in 2007?
Give a very brief answer. 0.72. What is the difference between the highest and the second highest Exports(as % of merchandise exports) of High income?
Offer a very short reply. 0.64. What is the difference between the highest and the second highest Exports(as % of merchandise exports) of Greenland?
Provide a succinct answer. 2.64. What is the difference between the highest and the second highest Exports(as % of merchandise exports) in Iceland?
Offer a terse response. 7.45. What is the difference between the highest and the second highest Exports(as % of merchandise exports) in Madagascar?
Ensure brevity in your answer.  9.69. What is the difference between the highest and the lowest Exports(as % of merchandise exports) in High income?
Provide a succinct answer. 4.2. What is the difference between the highest and the lowest Exports(as % of merchandise exports) of Greenland?
Provide a short and direct response. 4.78. What is the difference between the highest and the lowest Exports(as % of merchandise exports) of Iceland?
Give a very brief answer. 13.47. What is the difference between the highest and the lowest Exports(as % of merchandise exports) of Madagascar?
Your response must be concise. 29.48. 